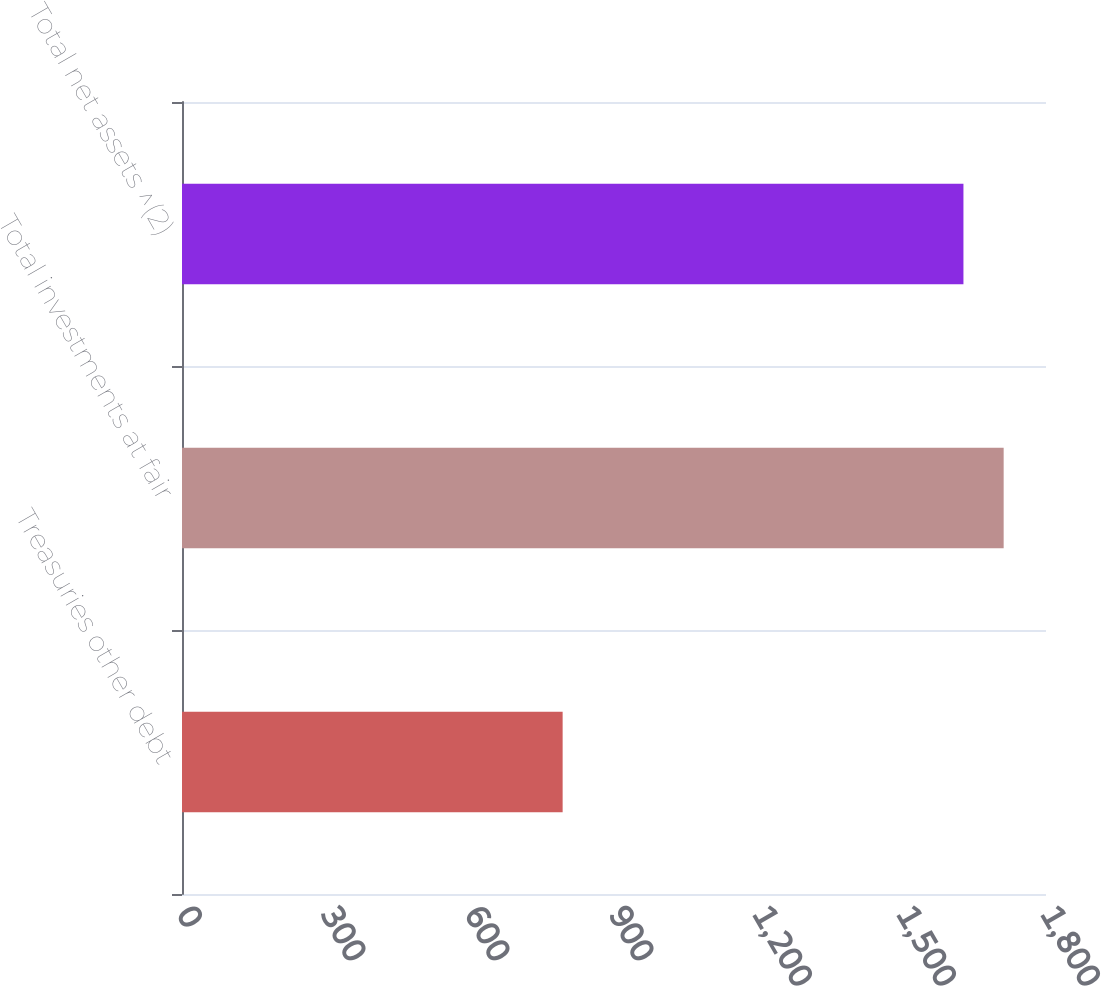Convert chart to OTSL. <chart><loc_0><loc_0><loc_500><loc_500><bar_chart><fcel>Treasuries other debt<fcel>Total investments at fair<fcel>Total net assets ^(2)<nl><fcel>793<fcel>1711.8<fcel>1628<nl></chart> 